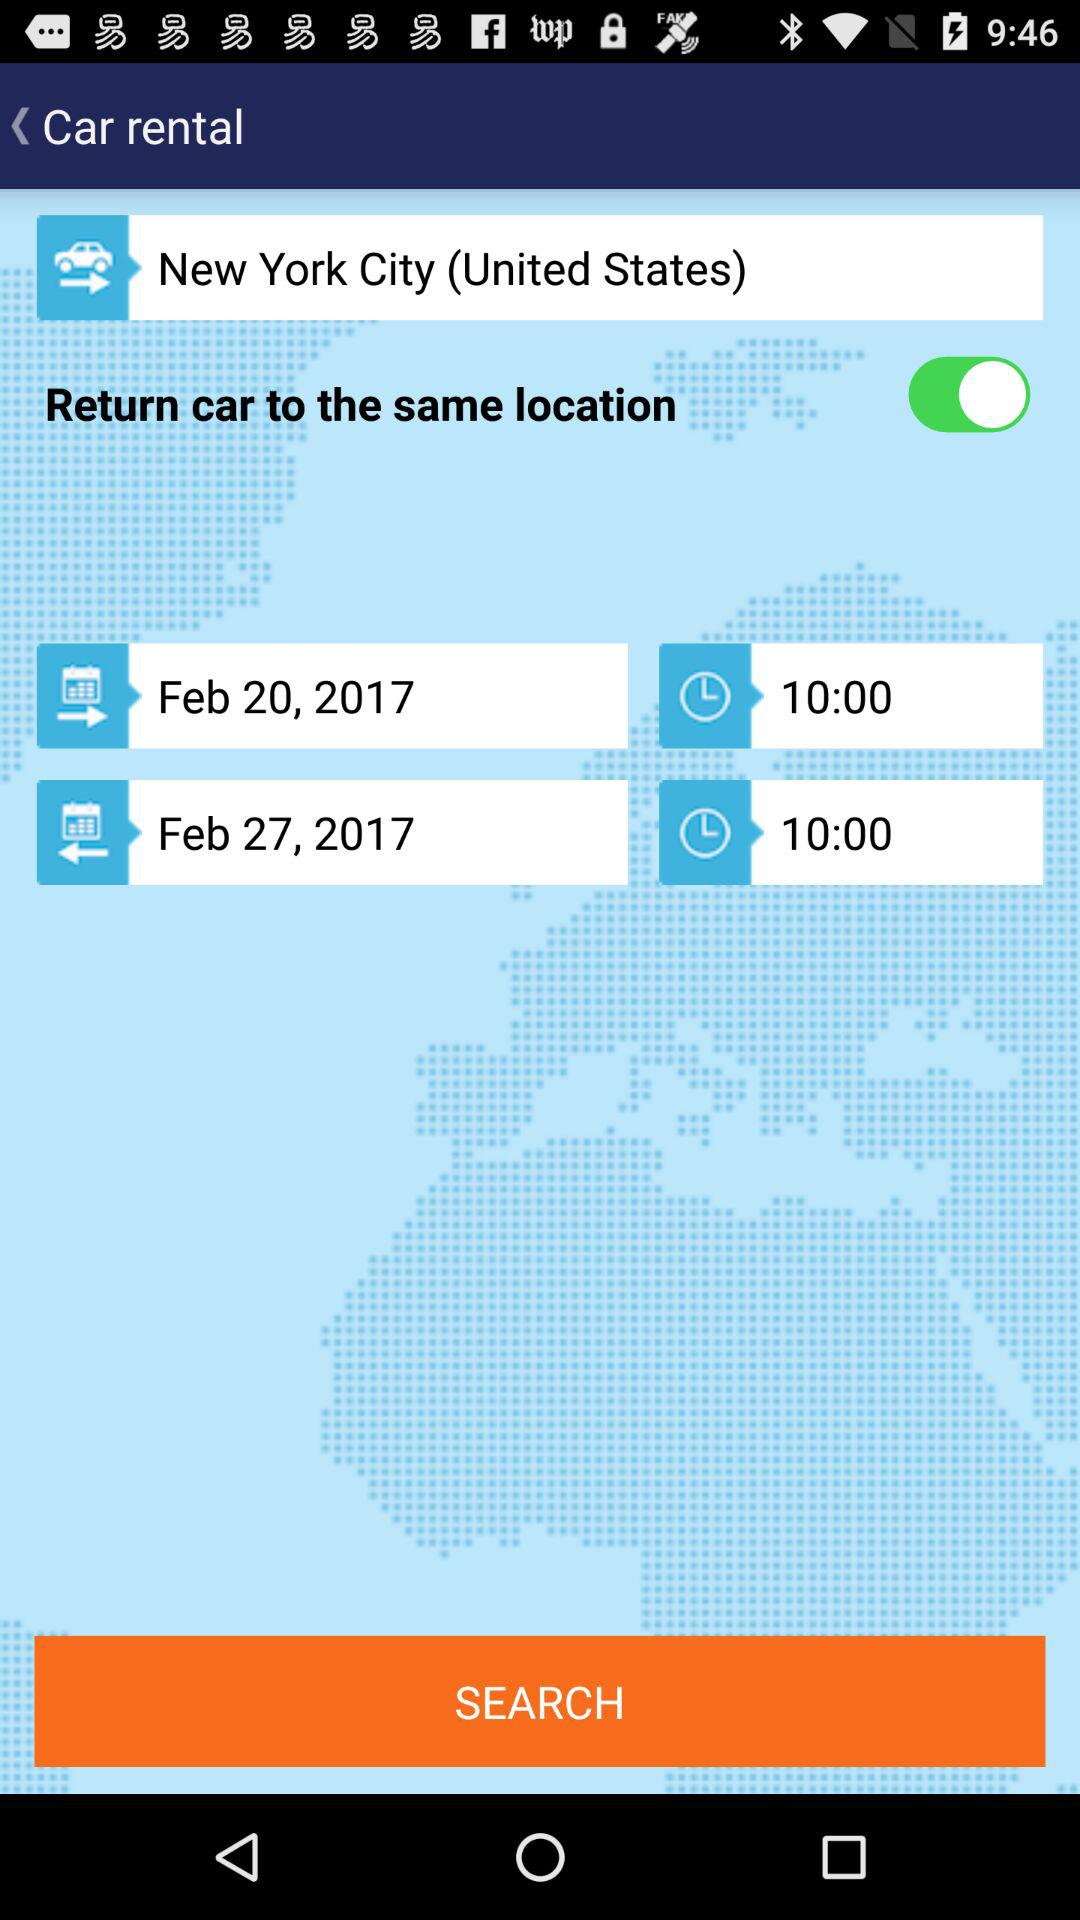What is the arrival date? The arrival date is February 27, 2017. 